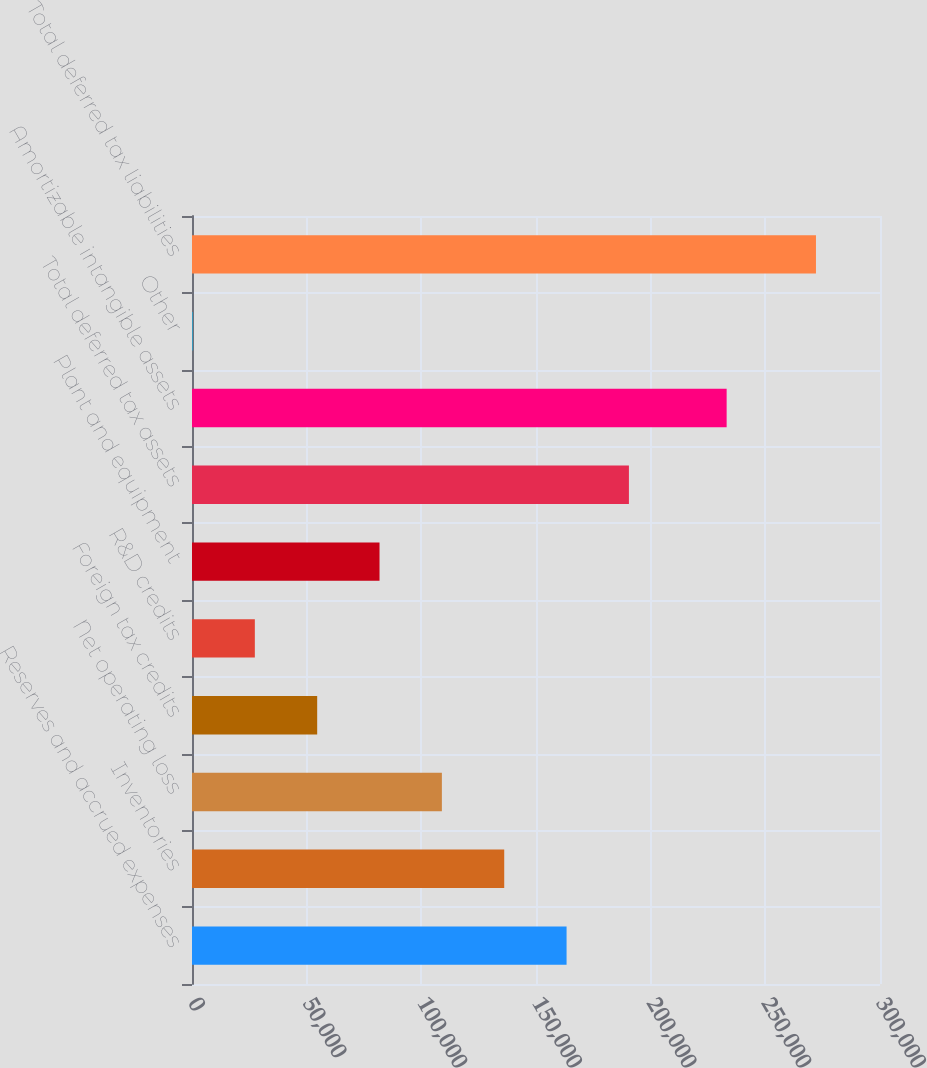Convert chart. <chart><loc_0><loc_0><loc_500><loc_500><bar_chart><fcel>Reserves and accrued expenses<fcel>Inventories<fcel>Net operating loss<fcel>Foreign tax credits<fcel>R&D credits<fcel>Plant and equipment<fcel>Total deferred tax assets<fcel>Amortizable intangible assets<fcel>Other<fcel>Total deferred tax liabilities<nl><fcel>163331<fcel>136145<fcel>108959<fcel>54585.8<fcel>27399.4<fcel>81772.2<fcel>190518<fcel>233130<fcel>213<fcel>272077<nl></chart> 